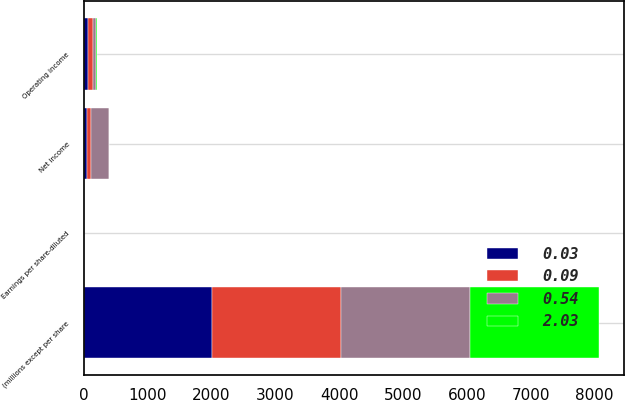<chart> <loc_0><loc_0><loc_500><loc_500><stacked_bar_chart><ecel><fcel>(millions except per share<fcel>Operating income<fcel>Net income<fcel>Earnings per share-diluted<nl><fcel>0.54<fcel>2018<fcel>38.8<fcel>271.4<fcel>2.03<nl><fcel>0.09<fcel>2017<fcel>83.9<fcel>69.3<fcel>0.54<nl><fcel>2.03<fcel>2016<fcel>16<fcel>11.1<fcel>0.09<nl><fcel>0.03<fcel>2015<fcel>65.5<fcel>47.9<fcel>0.37<nl></chart> 